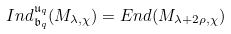<formula> <loc_0><loc_0><loc_500><loc_500>I n d _ { \mathfrak { b } _ { q } } ^ { \mathfrak { u } _ { q } } ( M _ { \lambda , \chi } ) = E n d ( M _ { \lambda + 2 \rho , \chi } )</formula> 